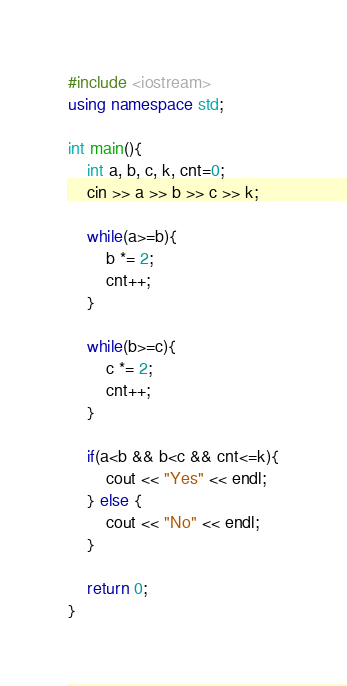<code> <loc_0><loc_0><loc_500><loc_500><_C++_>#include <iostream>
using namespace std;

int main(){
    int a, b, c, k, cnt=0;
    cin >> a >> b >> c >> k;

    while(a>=b){
        b *= 2;
        cnt++;
    }

    while(b>=c){
        c *= 2;
        cnt++;
    }

    if(a<b && b<c && cnt<=k){
        cout << "Yes" << endl;
    } else {
        cout << "No" << endl;
    }

    return 0;
}</code> 